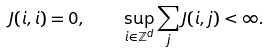Convert formula to latex. <formula><loc_0><loc_0><loc_500><loc_500>J ( i , i ) = 0 , \quad \sup _ { i \in { \mathbb { Z } } ^ { d } } \sum _ { j } J ( i , j ) < \infty .</formula> 